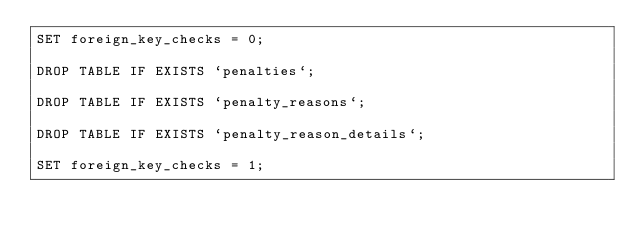<code> <loc_0><loc_0><loc_500><loc_500><_SQL_>SET foreign_key_checks = 0;

DROP TABLE IF EXISTS `penalties`;

DROP TABLE IF EXISTS `penalty_reasons`;

DROP TABLE IF EXISTS `penalty_reason_details`;

SET foreign_key_checks = 1;
</code> 